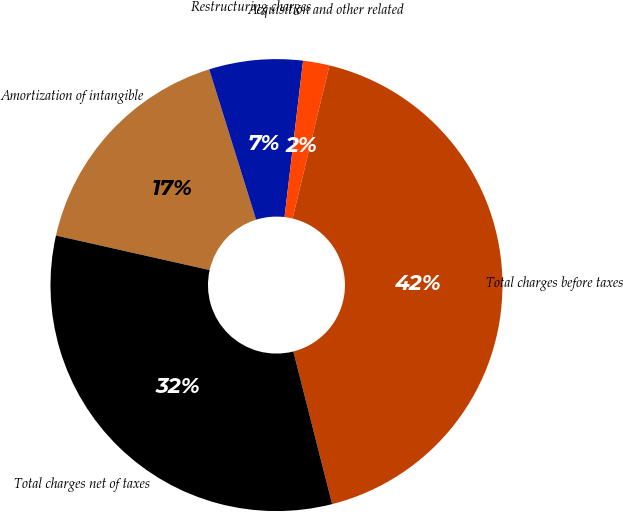Convert chart to OTSL. <chart><loc_0><loc_0><loc_500><loc_500><pie_chart><fcel>Amortization of intangible<fcel>Restructuring charges<fcel>Acquisition and other related<fcel>Total charges before taxes<fcel>Total charges net of taxes<nl><fcel>16.67%<fcel>6.69%<fcel>1.89%<fcel>42.27%<fcel>32.48%<nl></chart> 